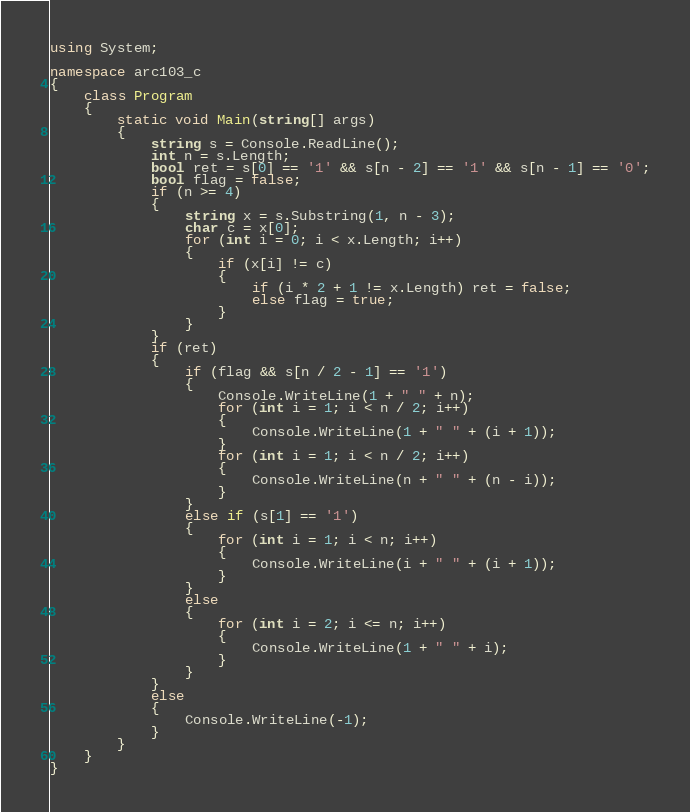Convert code to text. <code><loc_0><loc_0><loc_500><loc_500><_C#_>using System;

namespace arc103_c
{
	class Program
	{
		static void Main(string[] args)
		{
			string s = Console.ReadLine();
			int n = s.Length;
			bool ret = s[0] == '1' && s[n - 2] == '1' && s[n - 1] == '0';
			bool flag = false;
			if (n >= 4)
			{
				string x = s.Substring(1, n - 3);
				char c = x[0];
				for (int i = 0; i < x.Length; i++)
				{
					if (x[i] != c)
					{
						if (i * 2 + 1 != x.Length) ret = false;
						else flag = true;
					}
				}
			}
			if (ret)
			{
				if (flag && s[n / 2 - 1] == '1')
				{
					Console.WriteLine(1 + " " + n);
					for (int i = 1; i < n / 2; i++)
					{
						Console.WriteLine(1 + " " + (i + 1));
					}
					for (int i = 1; i < n / 2; i++)
					{
						Console.WriteLine(n + " " + (n - i));
					}
				}
				else if (s[1] == '1')
				{
					for (int i = 1; i < n; i++)
					{
						Console.WriteLine(i + " " + (i + 1));
					}
				}
				else
				{
					for (int i = 2; i <= n; i++)
					{
						Console.WriteLine(1 + " " + i);
					}
				}
			}
			else
			{
				Console.WriteLine(-1);
			}
		}
	}
}</code> 